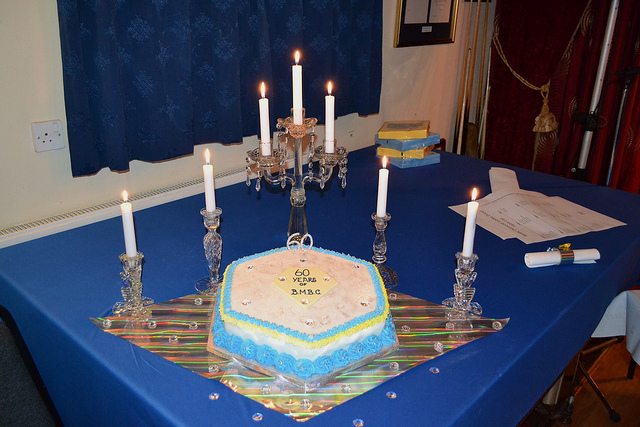Read all the text in this image. 60 of BMBC 